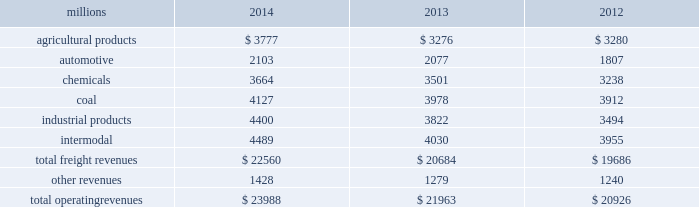Notes to the consolidated financial statements union pacific corporation and subsidiary companies for purposes of this report , unless the context otherwise requires , all references herein to the 201ccorporation 201d , 201ccompany 201d , 201cupc 201d , 201cwe 201d , 201cus 201d , and 201cour 201d mean union pacific corporation and its subsidiaries , including union pacific railroad company , which will be separately referred to herein as 201cuprr 201d or the 201crailroad 201d .
Nature of operations operations and segmentation 2013 we are a class i railroad operating in the u.s .
Our network includes 31974 route miles , linking pacific coast and gulf coast ports with the midwest and eastern u.s .
Gateways and providing several corridors to key mexican gateways .
We own 26012 miles and operate on the remainder pursuant to trackage rights or leases .
We serve the western two-thirds of the country and maintain coordinated schedules with other rail carriers for the handling of freight to and from the atlantic coast , the pacific coast , the southeast , the southwest , canada , and mexico .
Export and import traffic is moved through gulf coast and pacific coast ports and across the mexican and canadian borders .
The railroad , along with its subsidiaries and rail affiliates , is our one reportable operating segment .
Although we provide and review revenue by commodity group , we analyze the net financial results of the railroad as one segment due to the integrated nature of our rail network .
The table provides freight revenue by commodity group : millions 2014 2013 2012 .
Although our revenues are principally derived from customers domiciled in the u.s. , the ultimate points of origination or destination for some products transported by us are outside the u.s .
Each of our commodity groups includes revenue from shipments to and from mexico .
Included in the above table are revenues from our mexico business which amounted to $ 2.3 billion in 2014 , $ 2.1 billion in 2013 , and $ 1.9 billion in 2012 .
Basis of presentation 2013 the consolidated financial statements are presented in accordance with accounting principles generally accepted in the u.s .
( gaap ) as codified in the financial accounting standards board ( fasb ) accounting standards codification ( asc ) .
Significant accounting policies principles of consolidation 2013 the consolidated financial statements include the accounts of union pacific corporation and all of its subsidiaries .
Investments in affiliated companies ( 20% ( 20 % ) to 50% ( 50 % ) owned ) are accounted for using the equity method of accounting .
All intercompany transactions are eliminated .
We currently have no less than majority-owned investments that require consolidation under variable interest entity requirements .
Cash and cash equivalents 2013 cash equivalents consist of investments with original maturities of three months or less .
Accounts receivable 2013 accounts receivable includes receivables reduced by an allowance for doubtful accounts .
The allowance is based upon historical losses , credit worthiness of customers , and current economic conditions .
Receivables not expected to be collected in one year and the associated allowances are classified as other assets in our consolidated statements of financial position. .
What was the increase in total operating revenues in 2013? 
Computations: (21963 / 20926)
Answer: 1.04956. Notes to the consolidated financial statements union pacific corporation and subsidiary companies for purposes of this report , unless the context otherwise requires , all references herein to the 201ccorporation 201d , 201ccompany 201d , 201cupc 201d , 201cwe 201d , 201cus 201d , and 201cour 201d mean union pacific corporation and its subsidiaries , including union pacific railroad company , which will be separately referred to herein as 201cuprr 201d or the 201crailroad 201d .
Nature of operations operations and segmentation 2013 we are a class i railroad operating in the u.s .
Our network includes 31974 route miles , linking pacific coast and gulf coast ports with the midwest and eastern u.s .
Gateways and providing several corridors to key mexican gateways .
We own 26012 miles and operate on the remainder pursuant to trackage rights or leases .
We serve the western two-thirds of the country and maintain coordinated schedules with other rail carriers for the handling of freight to and from the atlantic coast , the pacific coast , the southeast , the southwest , canada , and mexico .
Export and import traffic is moved through gulf coast and pacific coast ports and across the mexican and canadian borders .
The railroad , along with its subsidiaries and rail affiliates , is our one reportable operating segment .
Although we provide and review revenue by commodity group , we analyze the net financial results of the railroad as one segment due to the integrated nature of our rail network .
The table provides freight revenue by commodity group : millions 2014 2013 2012 .
Although our revenues are principally derived from customers domiciled in the u.s. , the ultimate points of origination or destination for some products transported by us are outside the u.s .
Each of our commodity groups includes revenue from shipments to and from mexico .
Included in the above table are revenues from our mexico business which amounted to $ 2.3 billion in 2014 , $ 2.1 billion in 2013 , and $ 1.9 billion in 2012 .
Basis of presentation 2013 the consolidated financial statements are presented in accordance with accounting principles generally accepted in the u.s .
( gaap ) as codified in the financial accounting standards board ( fasb ) accounting standards codification ( asc ) .
Significant accounting policies principles of consolidation 2013 the consolidated financial statements include the accounts of union pacific corporation and all of its subsidiaries .
Investments in affiliated companies ( 20% ( 20 % ) to 50% ( 50 % ) owned ) are accounted for using the equity method of accounting .
All intercompany transactions are eliminated .
We currently have no less than majority-owned investments that require consolidation under variable interest entity requirements .
Cash and cash equivalents 2013 cash equivalents consist of investments with original maturities of three months or less .
Accounts receivable 2013 accounts receivable includes receivables reduced by an allowance for doubtful accounts .
The allowance is based upon historical losses , credit worthiness of customers , and current economic conditions .
Receivables not expected to be collected in one year and the associated allowances are classified as other assets in our consolidated statements of financial position. .
What was the 2014 rate of increase in total operating revenues? 
Computations: (23988 / 21963)
Answer: 1.0922. 